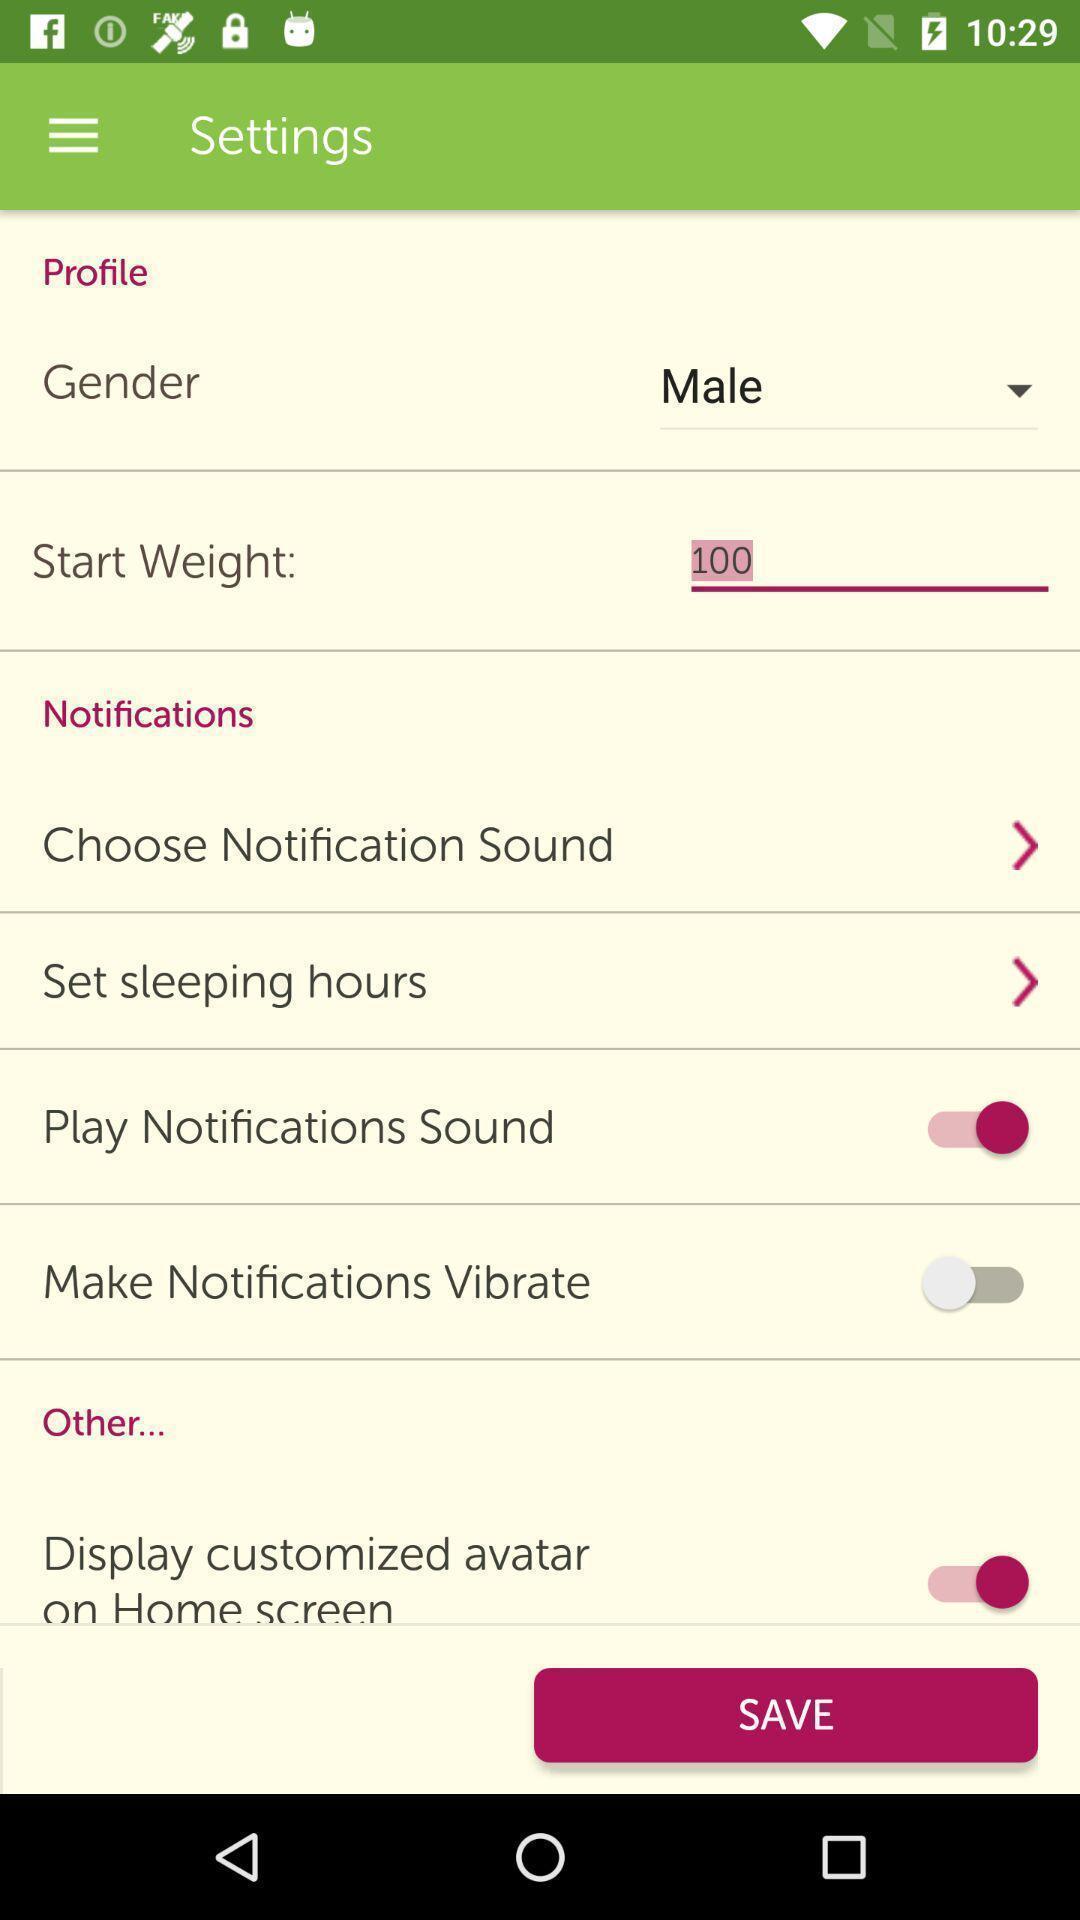What can you discern from this picture? Settings page with multiple options. 